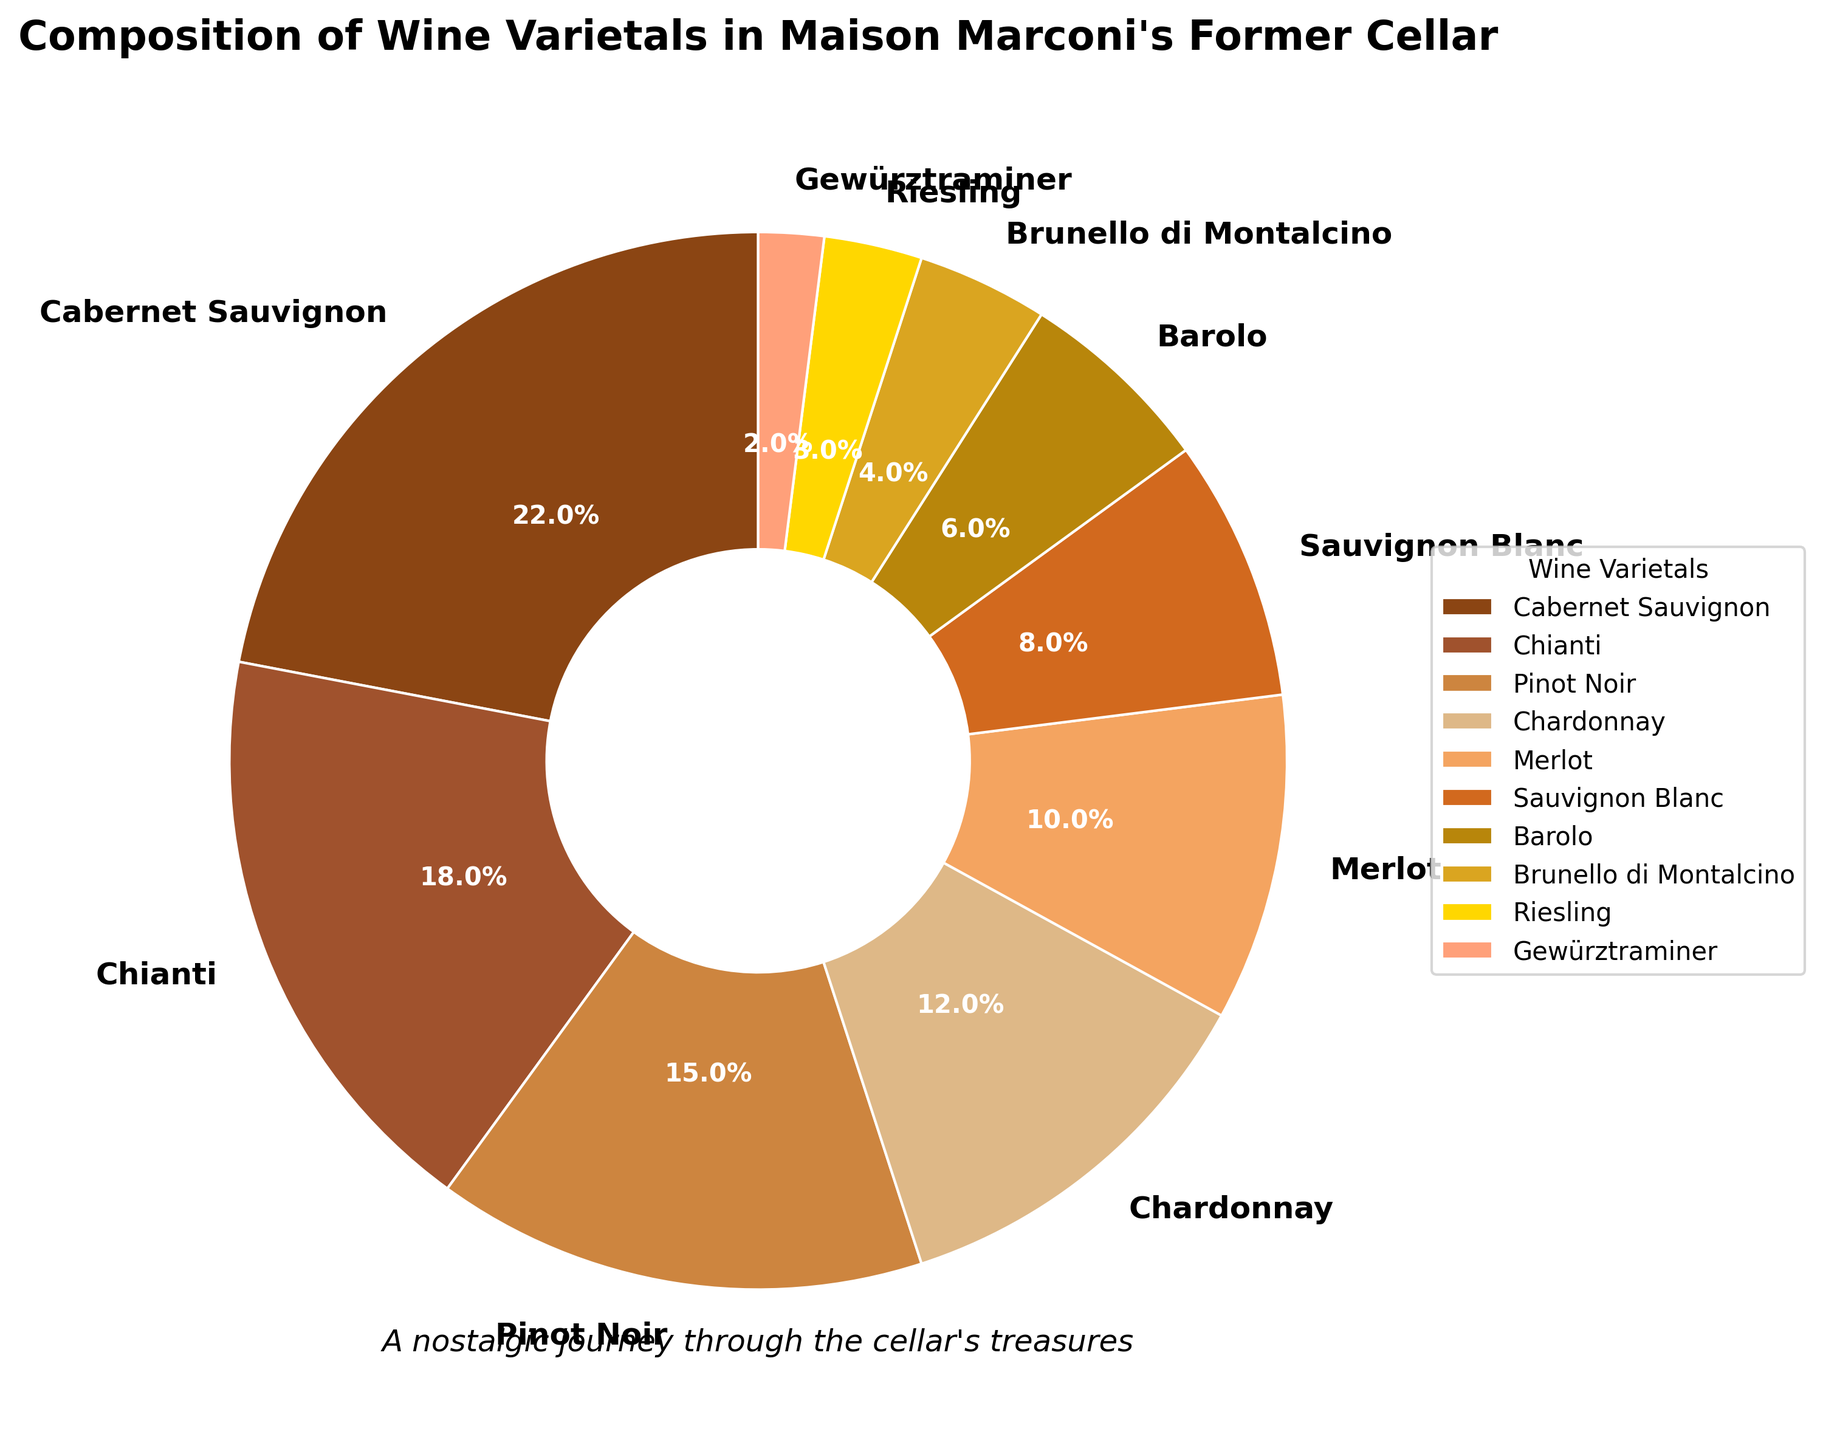what's the smallest percentage of wine varietal in the pie chart? The smallest percentage value can be found by looking at the slices of the pie chart and identifying the smallest one. In this case, it's Gewürztraminer with 2%.
Answer: 2% What's the difference in percentage between Cabernet Sauvignon and Chianti? Locate the percentages for Cabernet Sauvignon and Chianti in the pie chart, which are 22% and 18% respectively. The difference is 22% - 18%.
Answer: 4% Which wine varietal contributes a percentage in the single digits? Identify varietals whose percentages are less than 10% in the pie chart. These are Sauvignon Blanc (8%), Barolo (6%), Brunello di Montalcino (4%), Riesling (3%), and Gewürztraminer (2%).
Answer: Sauvignon Blanc, Barolo, Brunello di Montalcino, Riesling, Gewürztraminer Which wine varietal takes up the largest segment of the pie chart? Observe the pie chart slices and identify the one that occupies the largest area, which is Cabernet Sauvignon with 22%.
Answer: Cabernet Sauvignon How many wine varietals have a percentage greater than 10%? By inspecting the pie chart, the varietals with percentages greater than 10% are Cabernet Sauvignon (22%), Chianti (18%), Pinot Noir (15%), Chardonnay (12%), and Merlot (10%). There are 5 such varietals.
Answer: 5 What's the total percentage of wine varietals that are red wines? Red wines in the pie chart are Cabernet Sauvignon (22%), Chianti (18%), Pinot Noir (15%), Merlot (10%), Barolo (6%), and Brunello di Montalcino (4%). Add these percentages: 22% + 18% + 15% + 10% + 6% + 4%.
Answer: 75% How does the Chardonnay slice compare visually to the Pinot Noir slice? Visually, the Chardonnay slice is slightly smaller than the Pinot Noir slice. Look at their locations on the chart and compare their sizes and percentages: Chardonnay is 12% and Pinot Noir is 15%.
Answer: Chardonnay slice is smaller Which segment is the third largest in the composition? After Cabernet Sauvignon and Chianti, the next largest segment in the pie chart is Pinot Noir with 15%.
Answer: Pinot Noir What’s the sum of the percentages for the top three wine varietals? The top three wine varietals are Cabernet Sauvignon (22%), Chianti (18%), and Pinot Noir (15%). Add these percentages: 22% + 18% + 15%.
Answer: 55% Which varietal in the legend uses a golden color? Observe the legend next to the pie chart to identify which wine varietal is represented with a golden color. That varietal is Brunello di Montalcino.
Answer: Brunello di Montalcino 